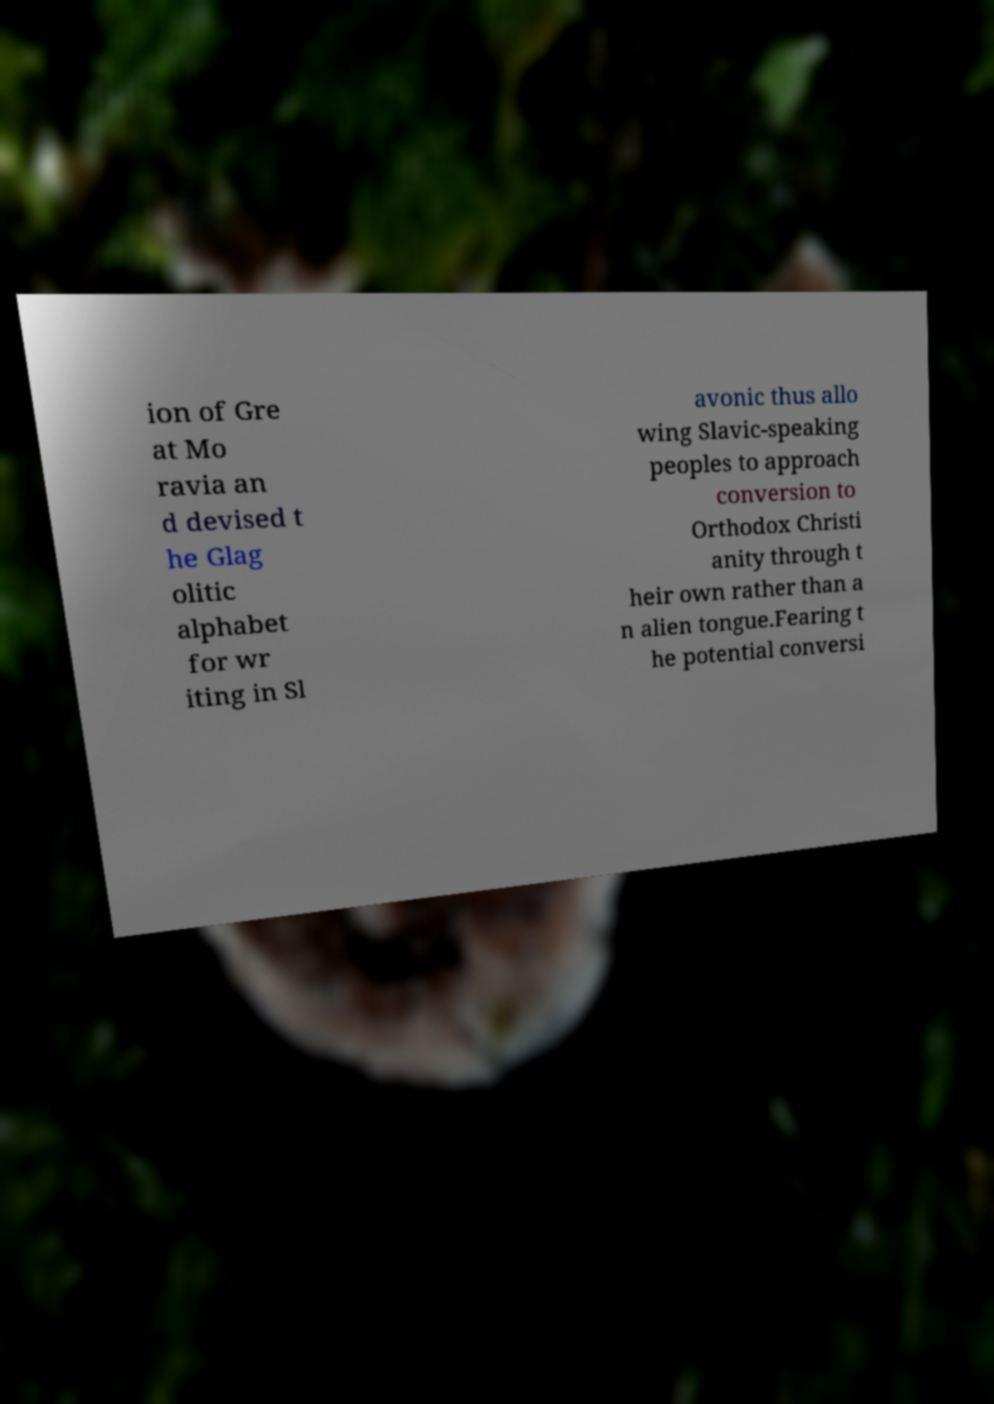Please read and relay the text visible in this image. What does it say? ion of Gre at Mo ravia an d devised t he Glag olitic alphabet for wr iting in Sl avonic thus allo wing Slavic-speaking peoples to approach conversion to Orthodox Christi anity through t heir own rather than a n alien tongue.Fearing t he potential conversi 